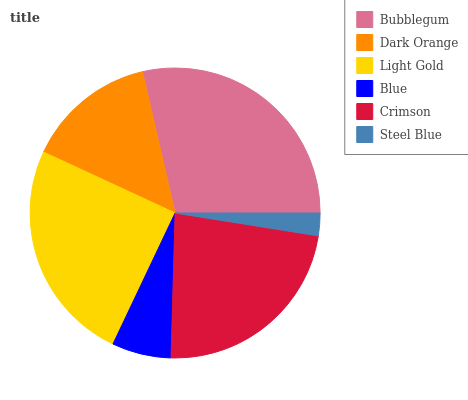Is Steel Blue the minimum?
Answer yes or no. Yes. Is Bubblegum the maximum?
Answer yes or no. Yes. Is Dark Orange the minimum?
Answer yes or no. No. Is Dark Orange the maximum?
Answer yes or no. No. Is Bubblegum greater than Dark Orange?
Answer yes or no. Yes. Is Dark Orange less than Bubblegum?
Answer yes or no. Yes. Is Dark Orange greater than Bubblegum?
Answer yes or no. No. Is Bubblegum less than Dark Orange?
Answer yes or no. No. Is Crimson the high median?
Answer yes or no. Yes. Is Dark Orange the low median?
Answer yes or no. Yes. Is Light Gold the high median?
Answer yes or no. No. Is Bubblegum the low median?
Answer yes or no. No. 